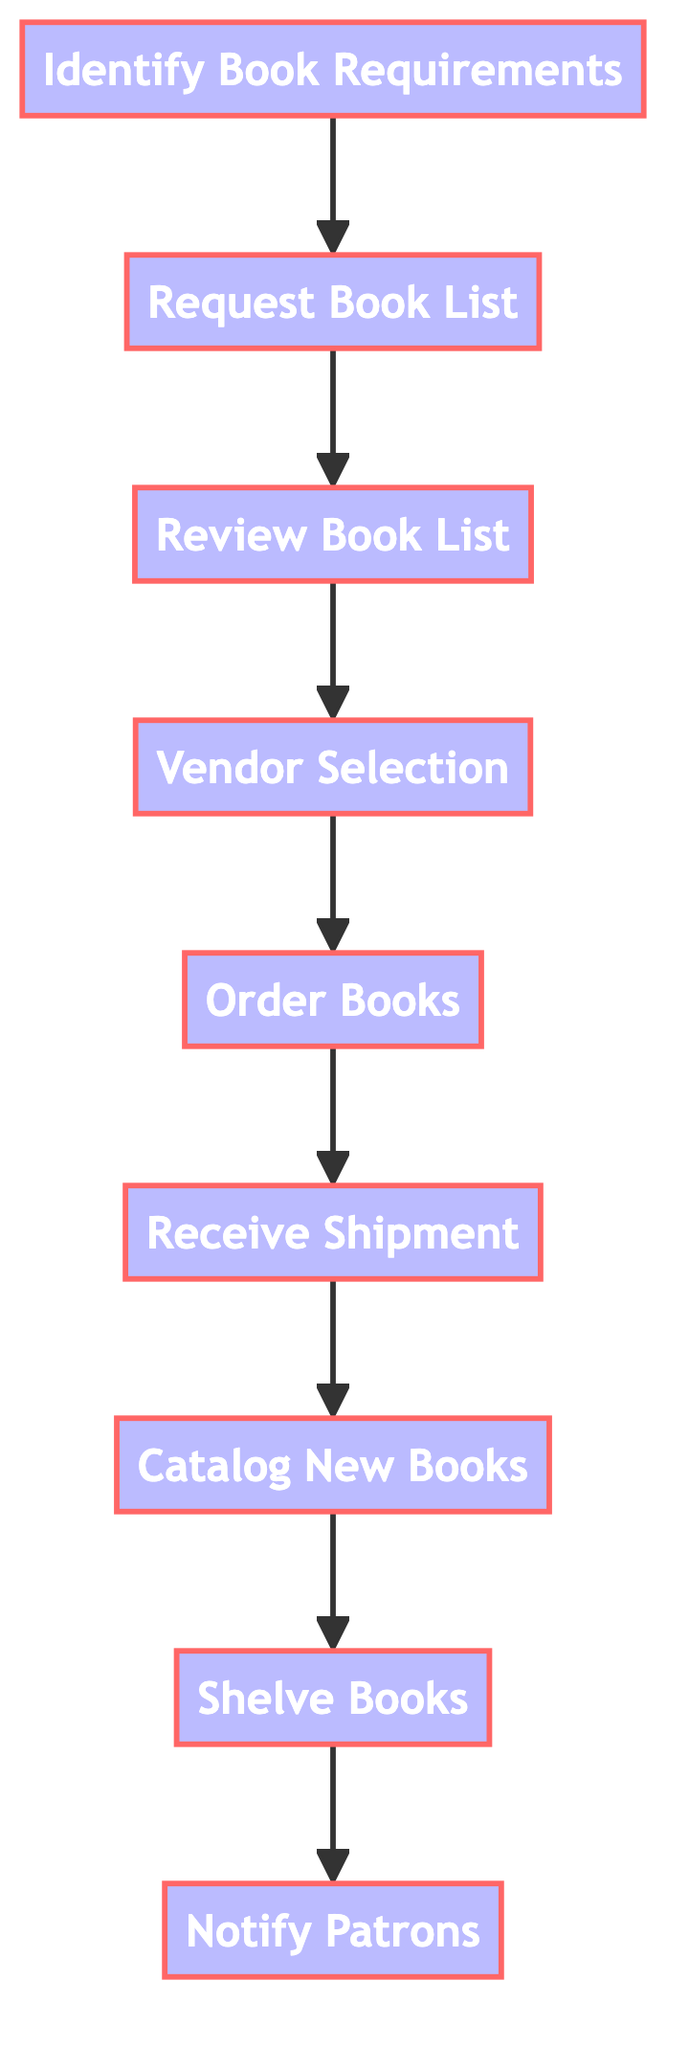What is the first step in the process? The first step is "Identify Book Requirements," as shown at the beginning of the flowchart.
Answer: Identify Book Requirements How many total steps are in the process? By counting each individual step in the diagram, we find there are nine steps from "Identify Book Requirements" to "Notify Patrons."
Answer: 9 Which step comes after "Review Book List"? "Vendor Selection" follows "Review Book List," as seen by the arrow pointing from the third node to the fourth node in the flowchart.
Answer: Vendor Selection What is the last step in the process? The last step, indicated as the final node in the flowchart, is "Notify Patrons."
Answer: Notify Patrons How many steps must be completed before "Catalog New Books"? To reach "Catalog New Books," steps "Receive Shipment" must be completed, meaning six total steps before it.
Answer: 6 Which step is directly before "Shelve Books"? The step directly preceding "Shelve Books" is "Catalog New Books," identified by the arrow leading into the eighth node.
Answer: Catalog New Books What is the relationship between "Order Books" and "Receive Shipment"? "Order Books" must be completed before "Receive Shipment," reflecting a direct dependency illustrated by the flowchart arrow.
Answer: Order Books Which step requires a list of recommended books? The step "Request Book List" requests a list from faculty and students, preceding the review process.
Answer: Request Book List How many decision points are shown in the diagram? The flowchart indicates a linear process without decision points; therefore, no decisions are made within the illustrated steps.
Answer: 0 